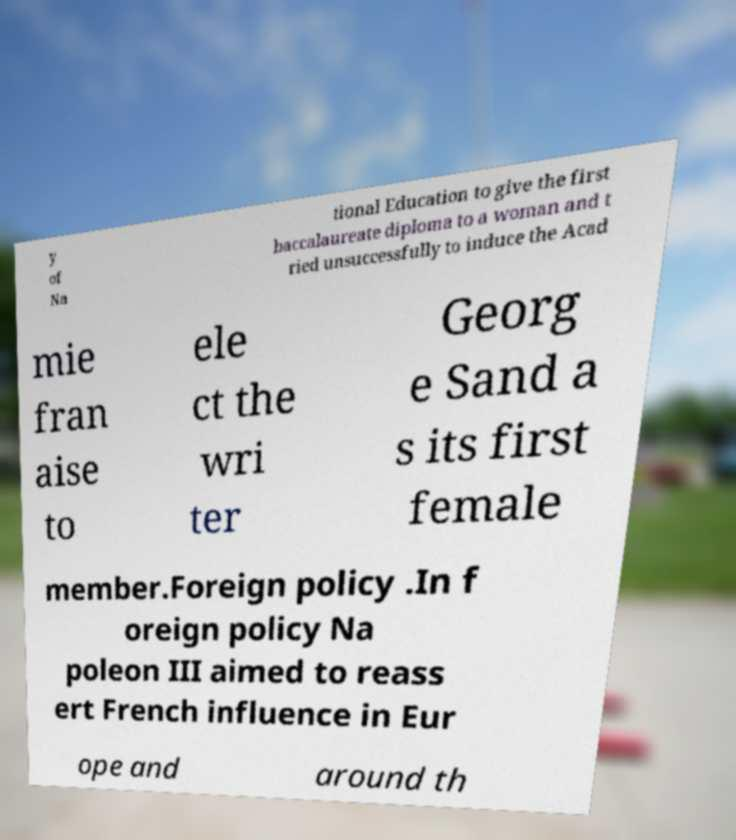Could you extract and type out the text from this image? y of Na tional Education to give the first baccalaureate diploma to a woman and t ried unsuccessfully to induce the Acad mie fran aise to ele ct the wri ter Georg e Sand a s its first female member.Foreign policy .In f oreign policy Na poleon III aimed to reass ert French influence in Eur ope and around th 